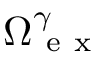<formula> <loc_0><loc_0><loc_500><loc_500>\Omega _ { e x } ^ { \gamma }</formula> 